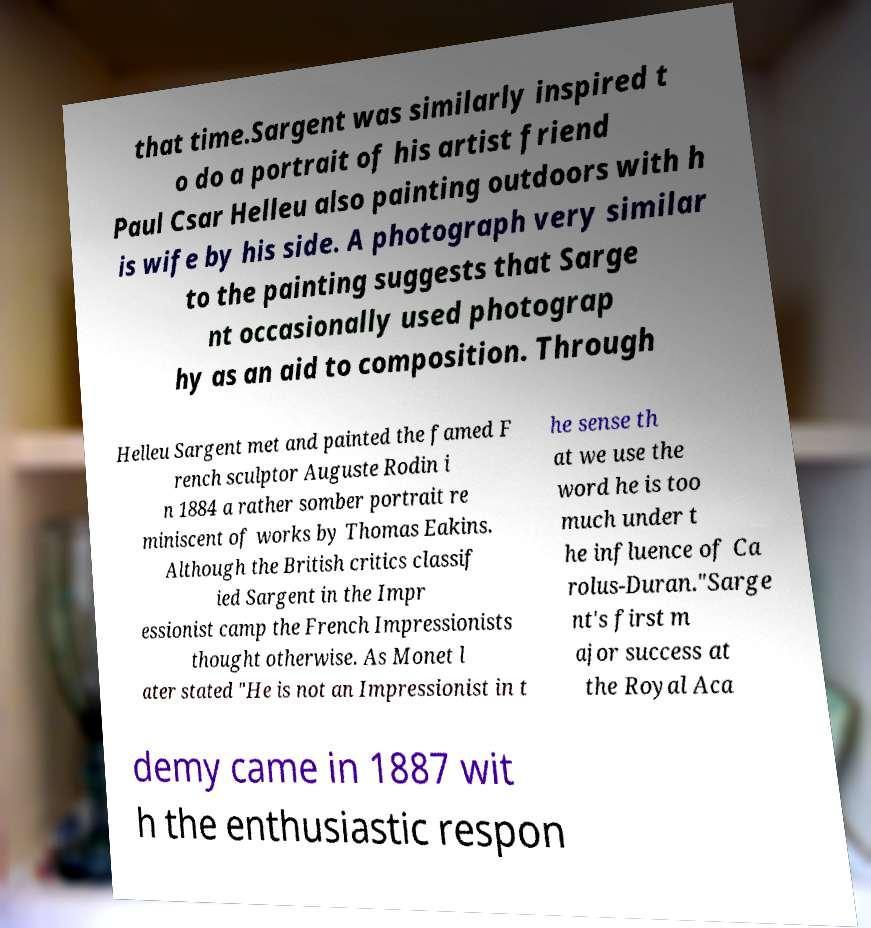There's text embedded in this image that I need extracted. Can you transcribe it verbatim? that time.Sargent was similarly inspired t o do a portrait of his artist friend Paul Csar Helleu also painting outdoors with h is wife by his side. A photograph very similar to the painting suggests that Sarge nt occasionally used photograp hy as an aid to composition. Through Helleu Sargent met and painted the famed F rench sculptor Auguste Rodin i n 1884 a rather somber portrait re miniscent of works by Thomas Eakins. Although the British critics classif ied Sargent in the Impr essionist camp the French Impressionists thought otherwise. As Monet l ater stated "He is not an Impressionist in t he sense th at we use the word he is too much under t he influence of Ca rolus-Duran."Sarge nt's first m ajor success at the Royal Aca demy came in 1887 wit h the enthusiastic respon 